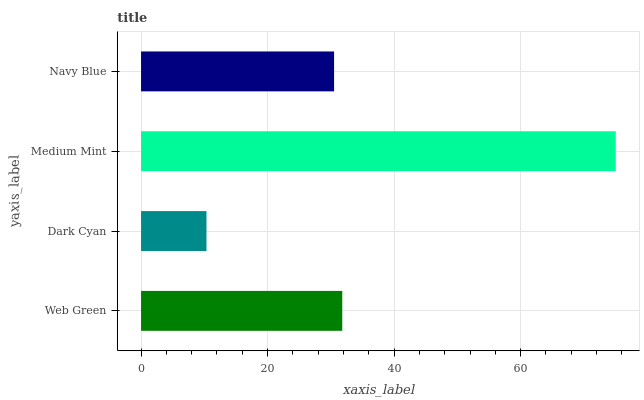Is Dark Cyan the minimum?
Answer yes or no. Yes. Is Medium Mint the maximum?
Answer yes or no. Yes. Is Medium Mint the minimum?
Answer yes or no. No. Is Dark Cyan the maximum?
Answer yes or no. No. Is Medium Mint greater than Dark Cyan?
Answer yes or no. Yes. Is Dark Cyan less than Medium Mint?
Answer yes or no. Yes. Is Dark Cyan greater than Medium Mint?
Answer yes or no. No. Is Medium Mint less than Dark Cyan?
Answer yes or no. No. Is Web Green the high median?
Answer yes or no. Yes. Is Navy Blue the low median?
Answer yes or no. Yes. Is Medium Mint the high median?
Answer yes or no. No. Is Medium Mint the low median?
Answer yes or no. No. 